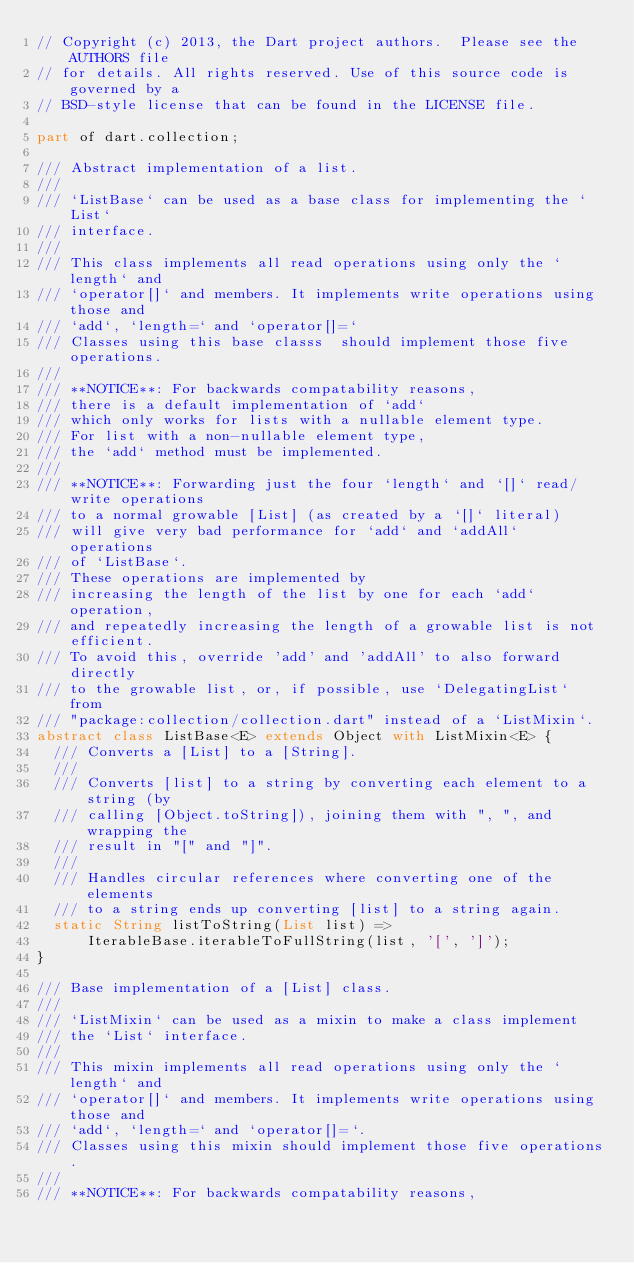<code> <loc_0><loc_0><loc_500><loc_500><_Dart_>// Copyright (c) 2013, the Dart project authors.  Please see the AUTHORS file
// for details. All rights reserved. Use of this source code is governed by a
// BSD-style license that can be found in the LICENSE file.

part of dart.collection;

/// Abstract implementation of a list.
///
/// `ListBase` can be used as a base class for implementing the `List`
/// interface.
///
/// This class implements all read operations using only the `length` and
/// `operator[]` and members. It implements write operations using those and
/// `add`, `length=` and `operator[]=`
/// Classes using this base classs  should implement those five operations.
///
/// **NOTICE**: For backwards compatability reasons,
/// there is a default implementation of `add`
/// which only works for lists with a nullable element type.
/// For list with a non-nullable element type,
/// the `add` method must be implemented.
///
/// **NOTICE**: Forwarding just the four `length` and `[]` read/write operations
/// to a normal growable [List] (as created by a `[]` literal)
/// will give very bad performance for `add` and `addAll` operations
/// of `ListBase`.
/// These operations are implemented by
/// increasing the length of the list by one for each `add` operation,
/// and repeatedly increasing the length of a growable list is not efficient.
/// To avoid this, override 'add' and 'addAll' to also forward directly
/// to the growable list, or, if possible, use `DelegatingList` from
/// "package:collection/collection.dart" instead of a `ListMixin`.
abstract class ListBase<E> extends Object with ListMixin<E> {
  /// Converts a [List] to a [String].
  ///
  /// Converts [list] to a string by converting each element to a string (by
  /// calling [Object.toString]), joining them with ", ", and wrapping the
  /// result in "[" and "]".
  ///
  /// Handles circular references where converting one of the elements
  /// to a string ends up converting [list] to a string again.
  static String listToString(List list) =>
      IterableBase.iterableToFullString(list, '[', ']');
}

/// Base implementation of a [List] class.
///
/// `ListMixin` can be used as a mixin to make a class implement
/// the `List` interface.
///
/// This mixin implements all read operations using only the `length` and
/// `operator[]` and members. It implements write operations using those and
/// `add`, `length=` and `operator[]=`.
/// Classes using this mixin should implement those five operations.
///
/// **NOTICE**: For backwards compatability reasons,</code> 